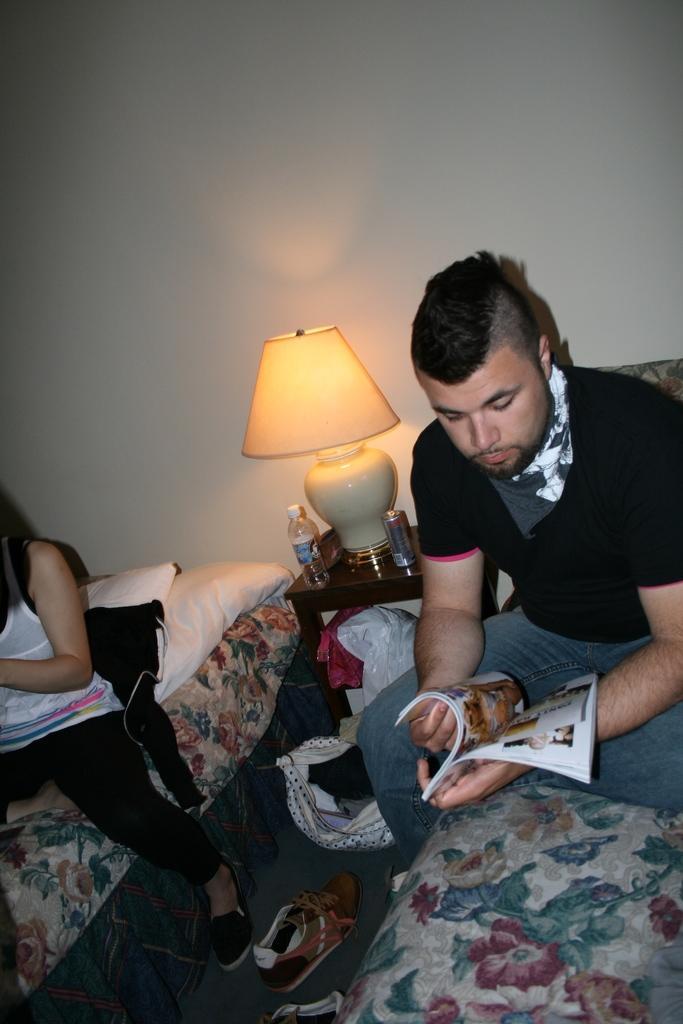Describe this image in one or two sentences. In the background we can see a wall. Here we can see a table and on the table we can see a table lamp, bottle and another object. We can see a man and a woman sitting on the beds separately. This man is holding a magazine in his hands. We can see footwear and a bag on the floor. 